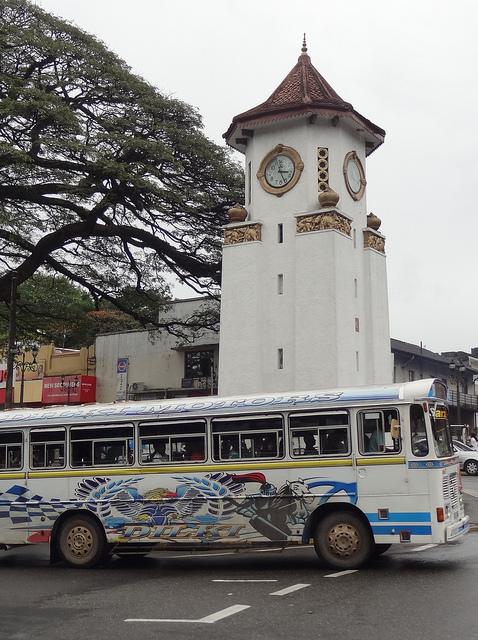Is the bus full or empty?
Write a very short answer. Full. What color is the bus?
Quick response, please. White. Is the clock digital?
Quick response, please. No. 